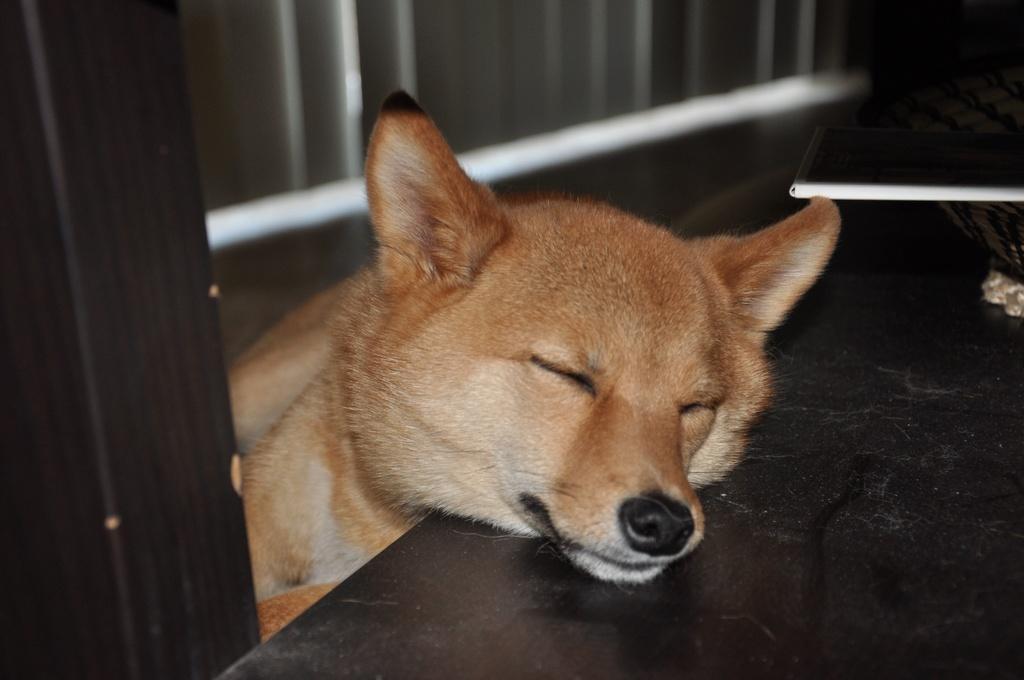How would you summarize this image in a sentence or two? In this picture we can observe a dog which is in brown color. The dog is sleeping on the table which is in black color. There is a book in the right side. 